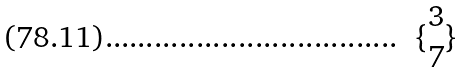Convert formula to latex. <formula><loc_0><loc_0><loc_500><loc_500>\{ \begin{matrix} 3 \\ 7 \end{matrix} \}</formula> 